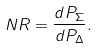Convert formula to latex. <formula><loc_0><loc_0><loc_500><loc_500>N R = \frac { d P _ { \Sigma } } { d P _ { \Delta } } .</formula> 